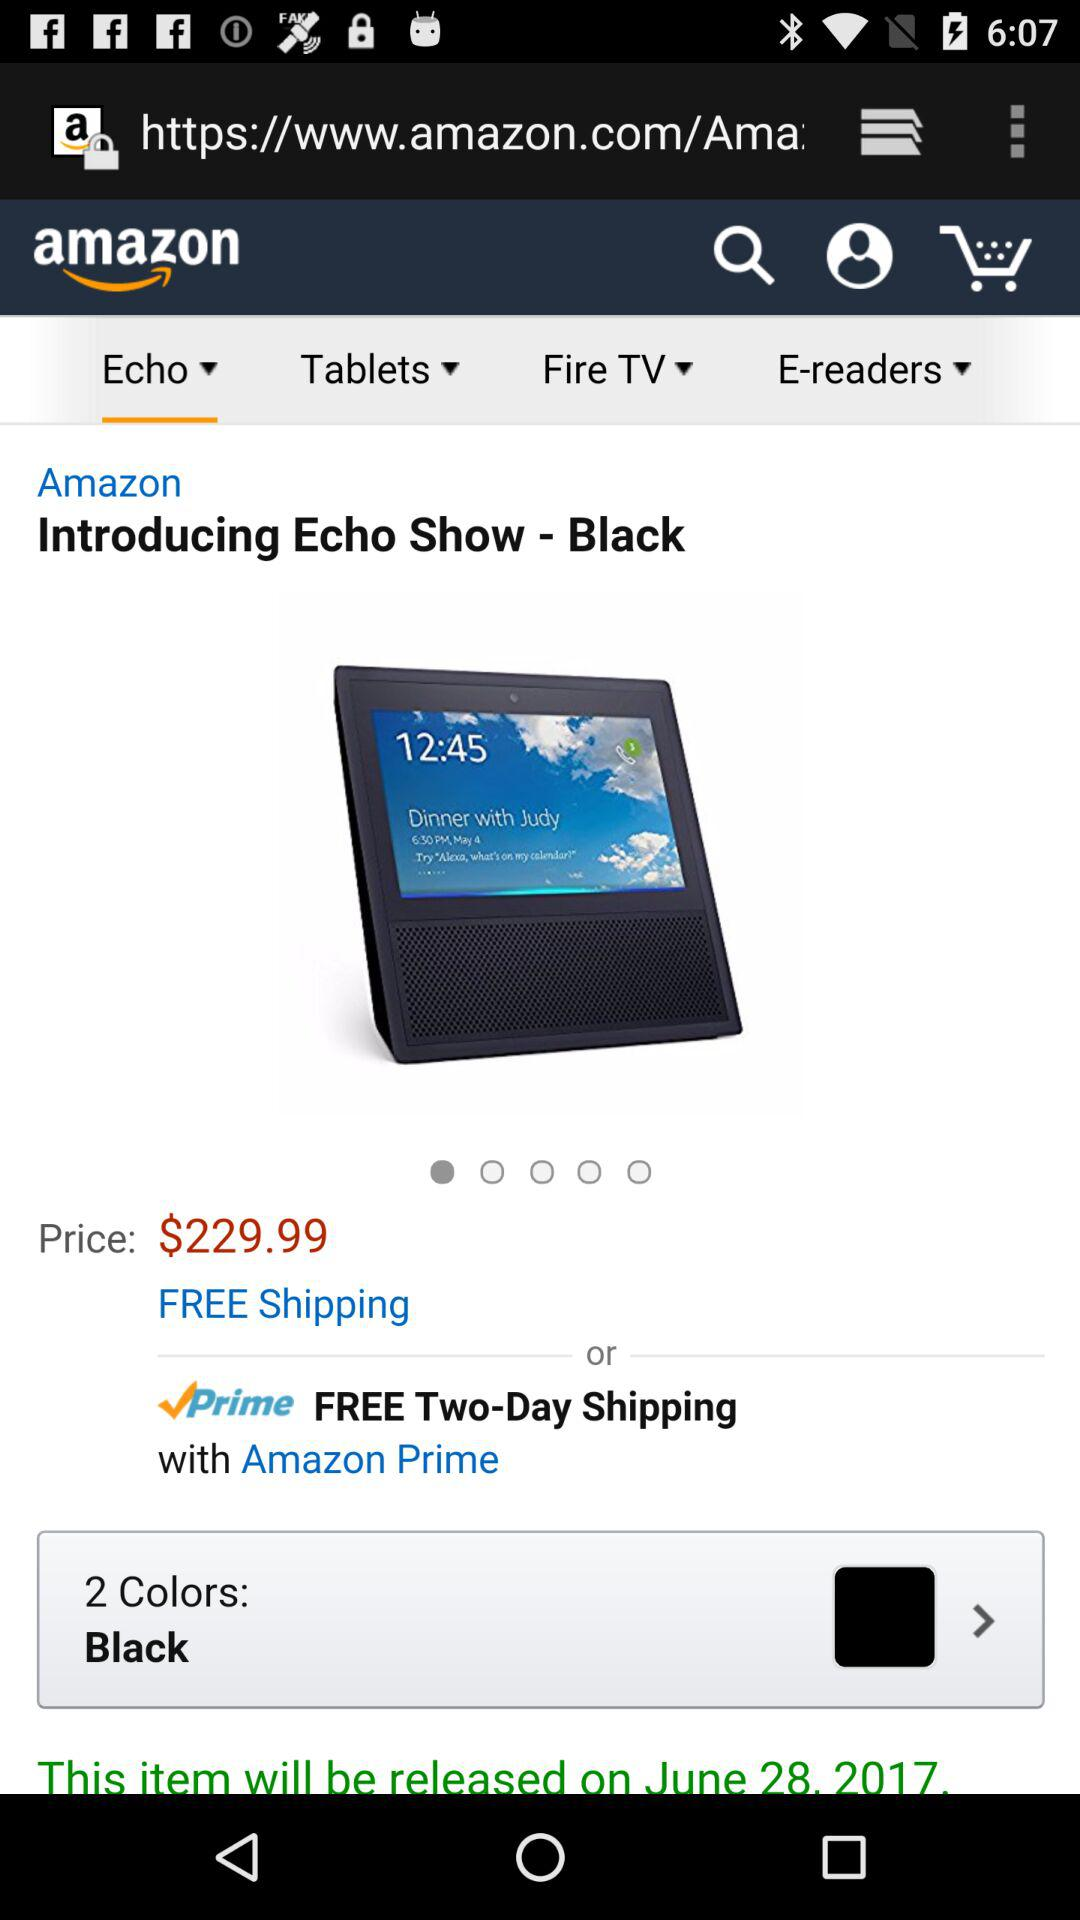What is the color? The color is black. 